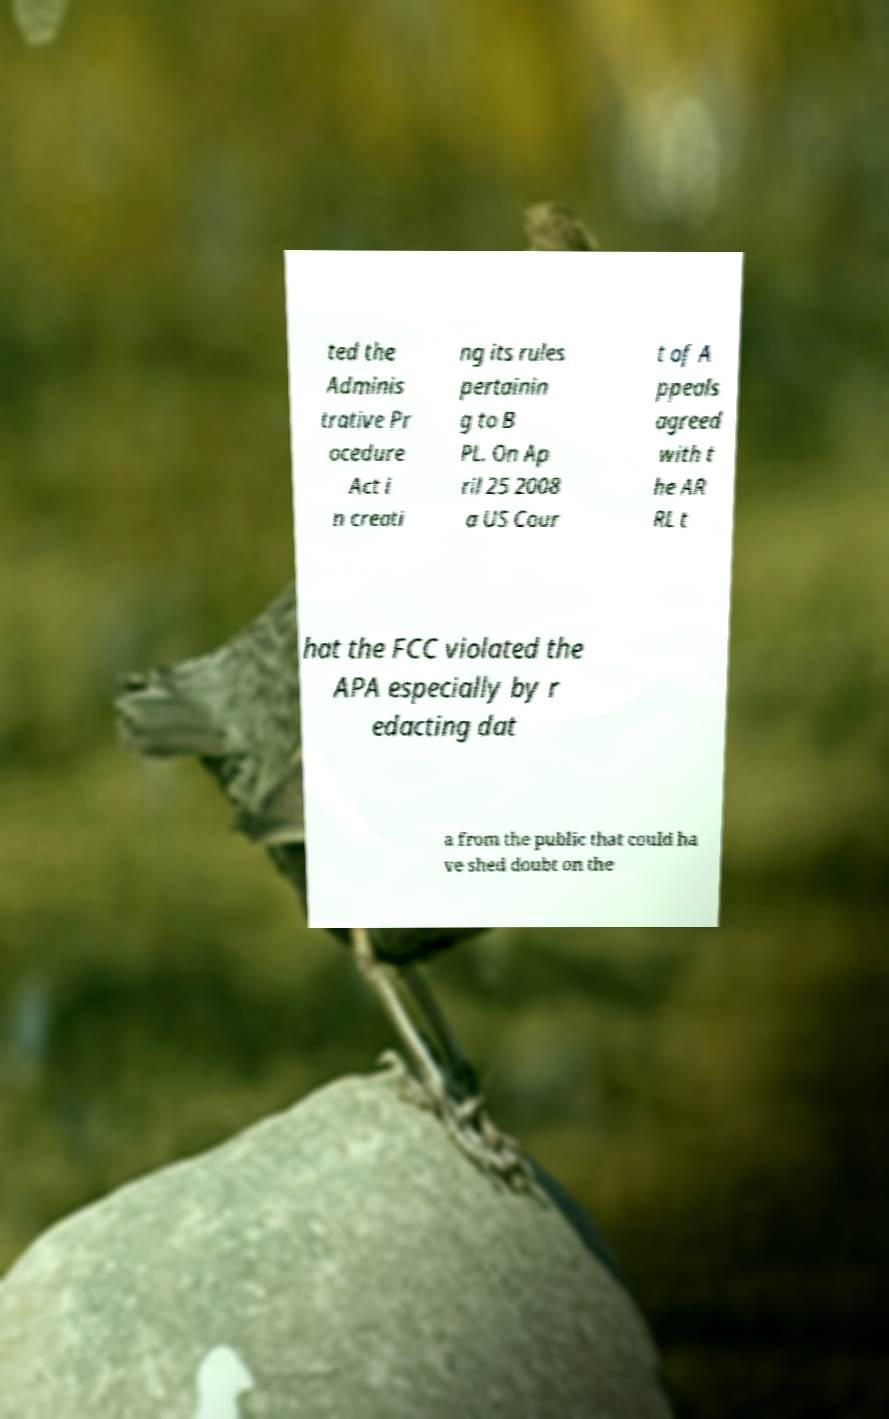What messages or text are displayed in this image? I need them in a readable, typed format. ted the Adminis trative Pr ocedure Act i n creati ng its rules pertainin g to B PL. On Ap ril 25 2008 a US Cour t of A ppeals agreed with t he AR RL t hat the FCC violated the APA especially by r edacting dat a from the public that could ha ve shed doubt on the 